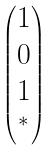<formula> <loc_0><loc_0><loc_500><loc_500>\begin{pmatrix} 1 \\ 0 \\ 1 \\ ^ { * } \end{pmatrix}</formula> 